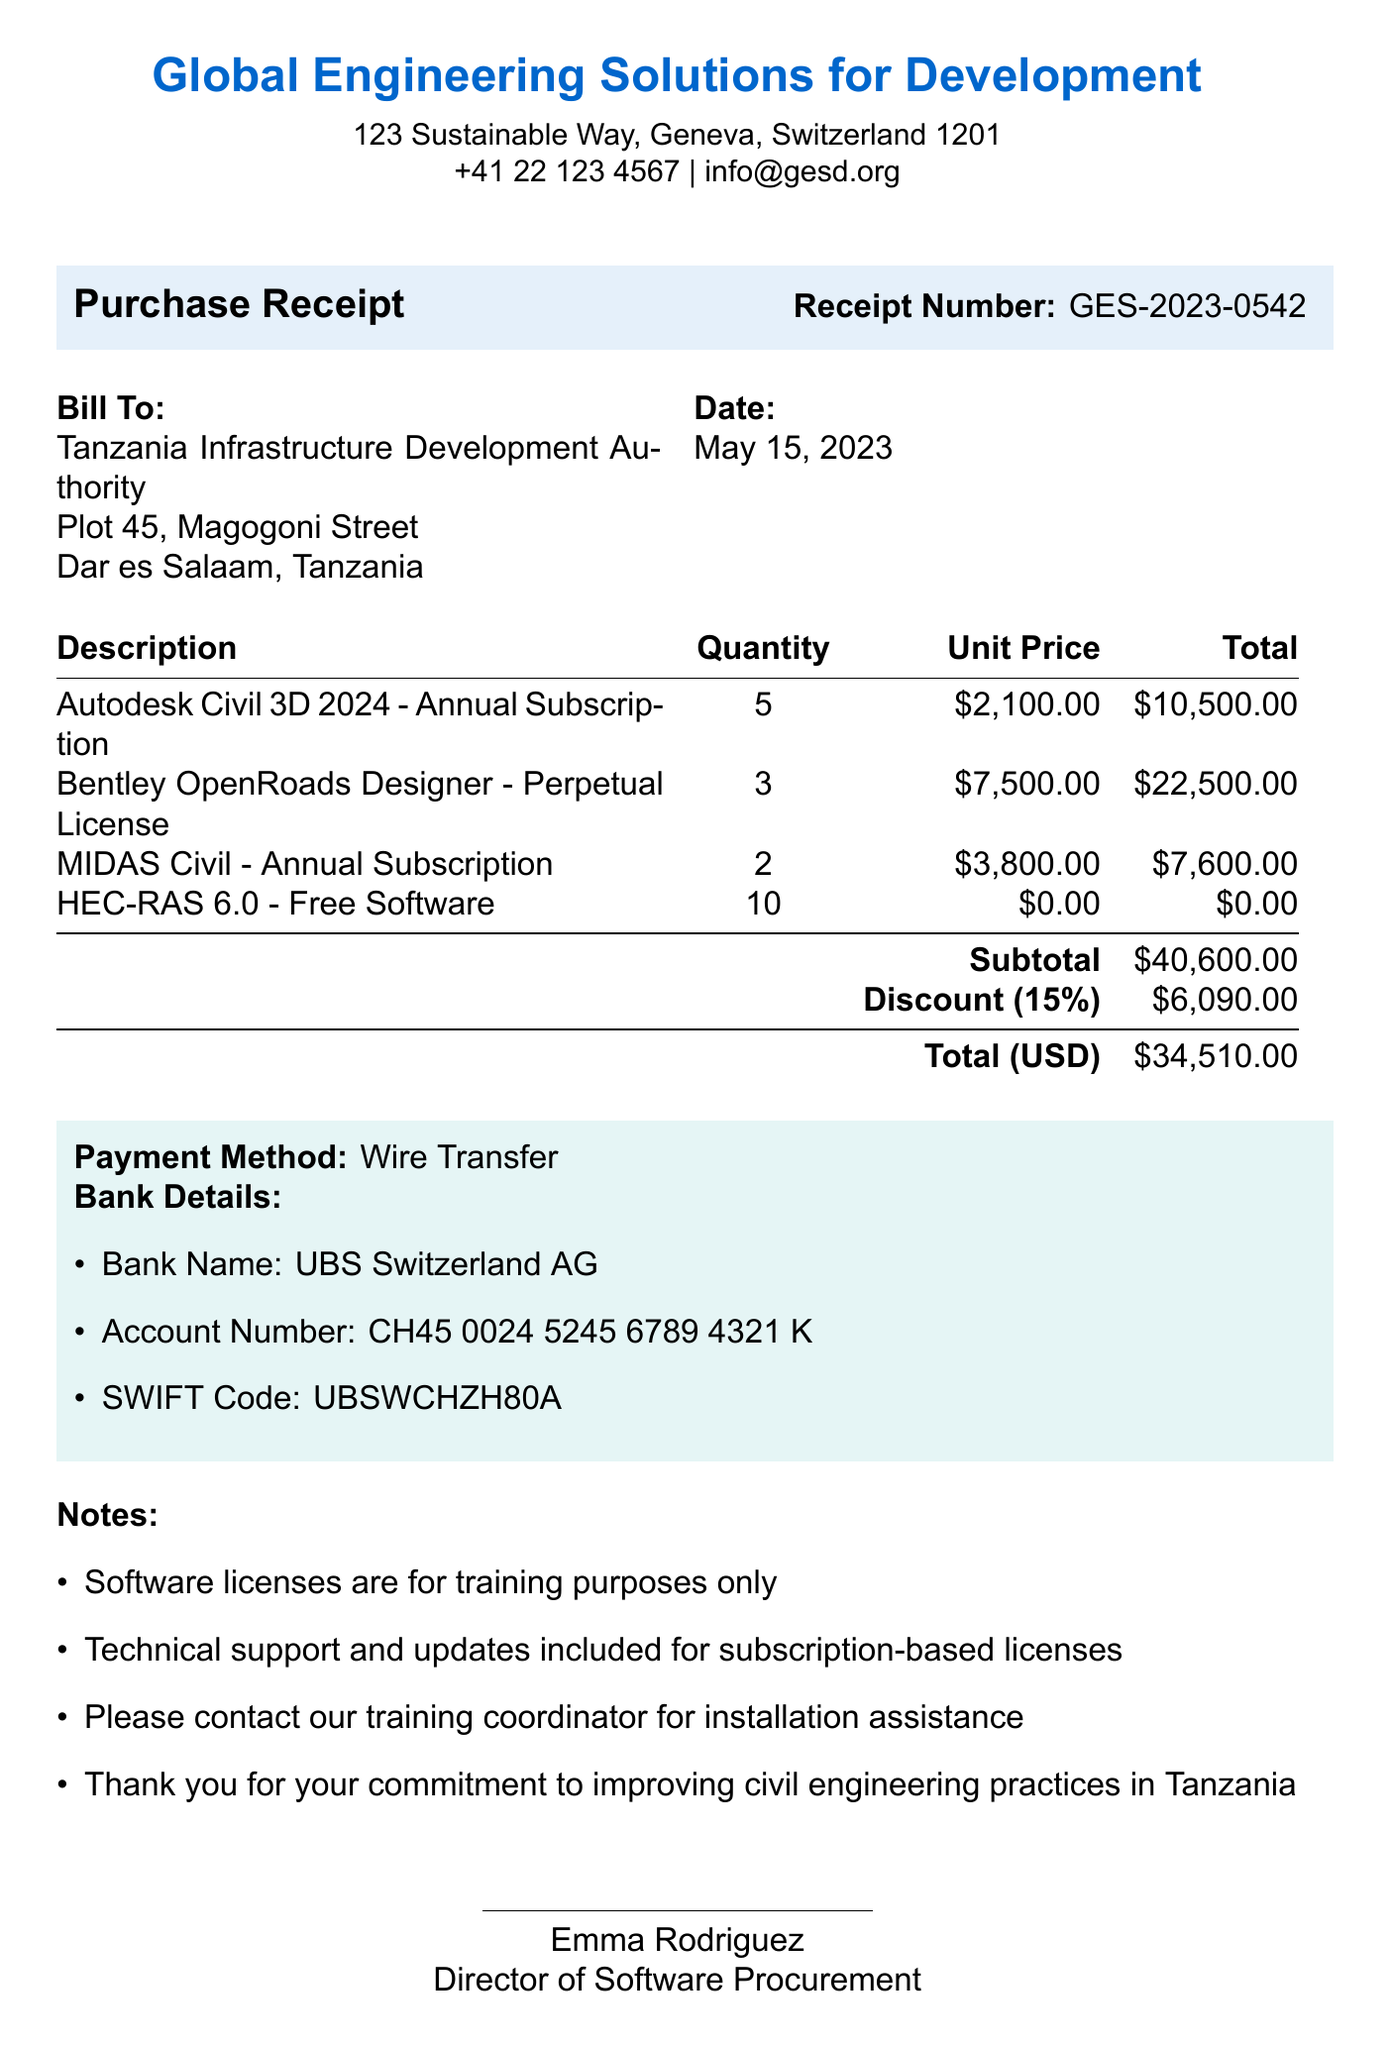What organization issued the receipt? The organization that issued the receipt is mentioned at the top as "Global Engineering Solutions for Development."
Answer: Global Engineering Solutions for Development What is the date of the receipt? The receipt date is clearly stated in the document as "May 15, 2023."
Answer: May 15, 2023 What is the total amount after discount? The total amount after applying the discount is computed and shown in the receipt as "$34,510.00."
Answer: $34,510.00 How many licenses of Autodesk Civil 3D were purchased? The quantity of Autodesk Civil 3D licenses purchased is shown in the itemized list as "5."
Answer: 5 What percentage discount was applied? The discount applied is written in the notes section as "15%."
Answer: 15% Who is the authorized signer on this receipt? The authorized signer at the end of the document is identified as "Emma Rodriguez."
Answer: Emma Rodriguez What is the payment method used for this purchase? The payment method for this transaction is specified in the document as "Wire Transfer."
Answer: Wire Transfer Which software is provided for free? The software listed as free in the receipt is "HEC-RAS 6.0."
Answer: HEC-RAS 6.0 How many installations of the free software can be utilized? The document states that there are "10 installations" available for the free software.
Answer: 10 installations 